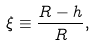<formula> <loc_0><loc_0><loc_500><loc_500>\xi \equiv \frac { R - h } { R } ,</formula> 